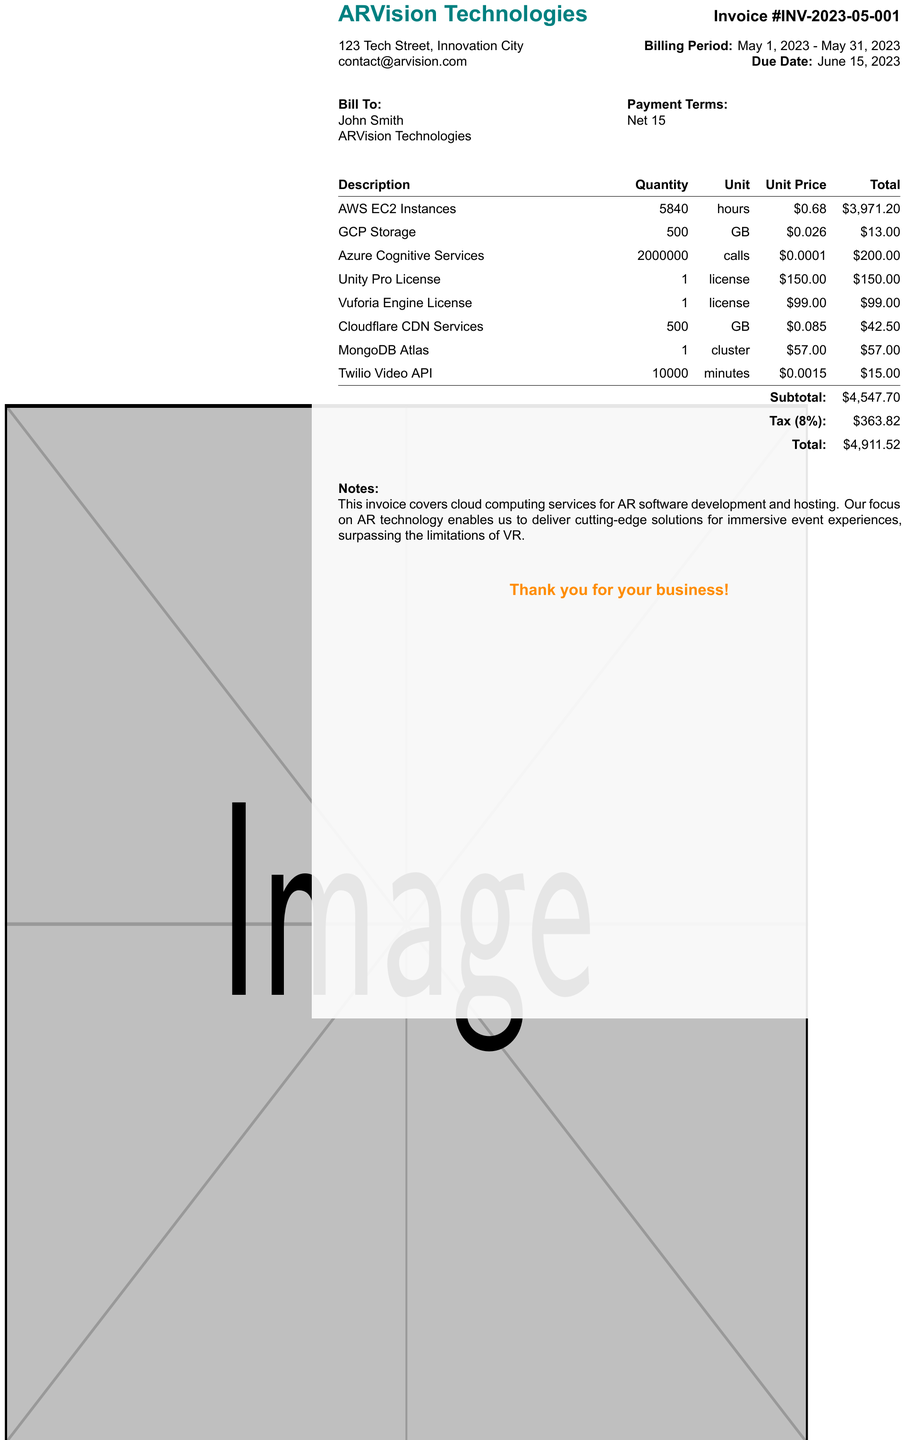what is the invoice number? The invoice number is a unique identifier for this document, which is IN-2023-05-001.
Answer: INV-2023-05-001 who is the client? The client name is specified on the invoice, which is John Smith.
Answer: John Smith what is the billing period? The billing period indicates the timeframe for which the services are charged, which is from May 1, 2023, to May 31, 2023.
Answer: May 1, 2023 - May 31, 2023 what is the total amount due? The total amount due is the final amount that needs to be paid as shown in the invoice, including subtotals and tax.
Answer: 4911.52 how much was spent on Amazon Web Services? The total cost for Amazon Web Services is calculated from the quantity and unit price listed in the invoice.
Answer: 3971.20 what percentage is the tax rate? The tax rate is the percentage used to calculate tax on the subtotal of the invoice.
Answer: 8% what services are included in the invoice? The invoice lists multiple services related to AR technology, which are detailed in the itemized list.
Answer: AWS EC2 Instances, GCP Storage, Azure Cognitive Services, Unity Pro License, Vuforia Engine License, Cloudflare CDN Services, MongoDB Atlas, Twilio Video API when is the due date for payment? The due date indicates the final date by which payment must be made, which is detailed in the invoice.
Answer: June 15, 2023 what are the payment terms? The payment terms outline the conditions under which payment should be made, specified in the invoice.
Answer: Net 15 